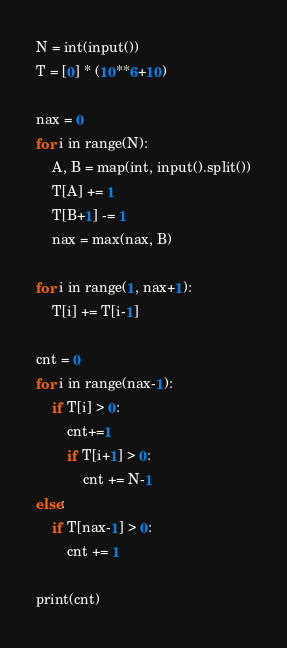<code> <loc_0><loc_0><loc_500><loc_500><_Python_>N = int(input())
T = [0] * (10**6+10)

nax = 0
for i in range(N):
    A, B = map(int, input().split())
    T[A] += 1
    T[B+1] -= 1
    nax = max(nax, B)

for i in range(1, nax+1):
    T[i] += T[i-1]

cnt = 0
for i in range(nax-1):
    if T[i] > 0:
        cnt+=1
        if T[i+1] > 0:
            cnt += N-1
else:
    if T[nax-1] > 0:
        cnt += 1

print(cnt)

</code> 